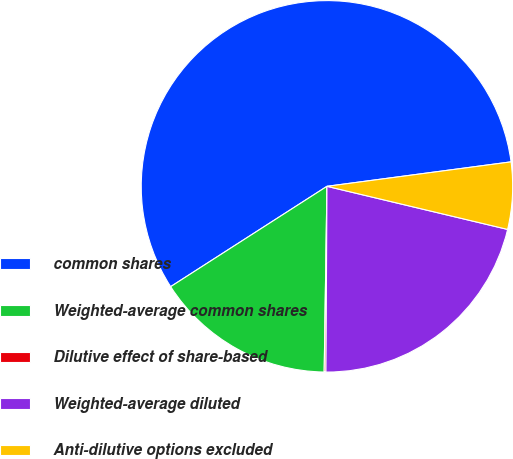Convert chart. <chart><loc_0><loc_0><loc_500><loc_500><pie_chart><fcel>common shares<fcel>Weighted-average common shares<fcel>Dilutive effect of share-based<fcel>Weighted-average diluted<fcel>Anti-dilutive options excluded<nl><fcel>56.98%<fcel>15.68%<fcel>0.15%<fcel>21.36%<fcel>5.83%<nl></chart> 